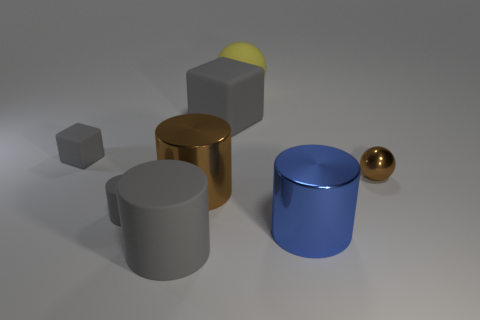Add 1 big metal things. How many objects exist? 9 Subtract all spheres. How many objects are left? 6 Subtract all large brown shiny cylinders. Subtract all large yellow objects. How many objects are left? 6 Add 2 big yellow rubber balls. How many big yellow rubber balls are left? 3 Add 8 big purple shiny objects. How many big purple shiny objects exist? 8 Subtract 2 gray cylinders. How many objects are left? 6 